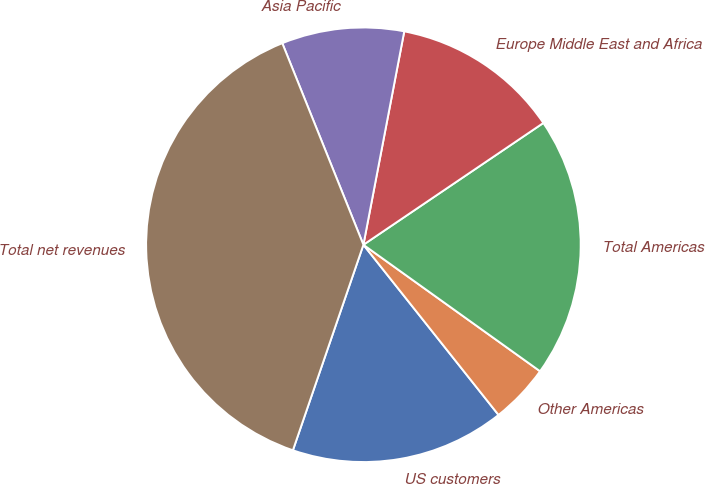<chart> <loc_0><loc_0><loc_500><loc_500><pie_chart><fcel>US customers<fcel>Other Americas<fcel>Total Americas<fcel>Europe Middle East and Africa<fcel>Asia Pacific<fcel>Total net revenues<nl><fcel>15.94%<fcel>4.43%<fcel>19.36%<fcel>12.52%<fcel>9.1%<fcel>38.65%<nl></chart> 